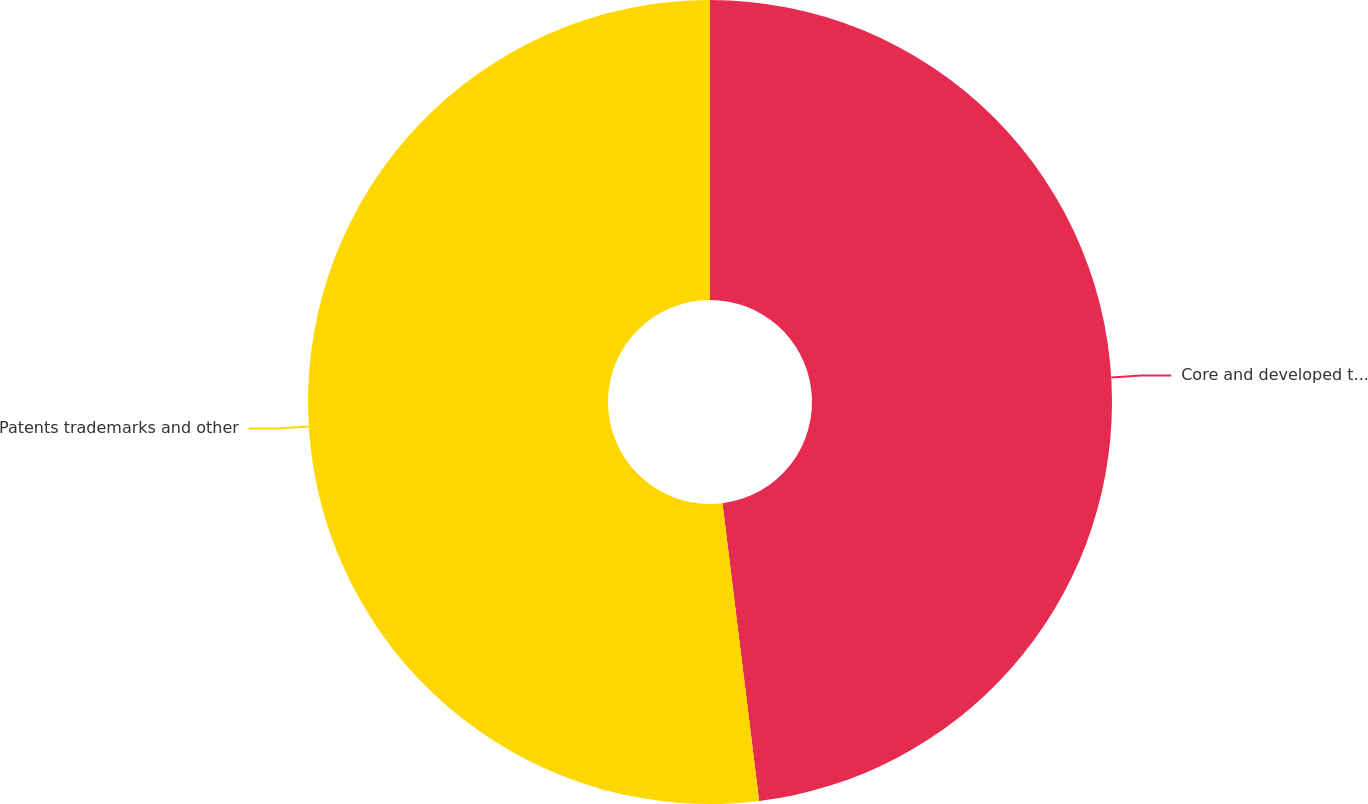<chart> <loc_0><loc_0><loc_500><loc_500><pie_chart><fcel>Core and developed technology<fcel>Patents trademarks and other<nl><fcel>48.05%<fcel>51.95%<nl></chart> 